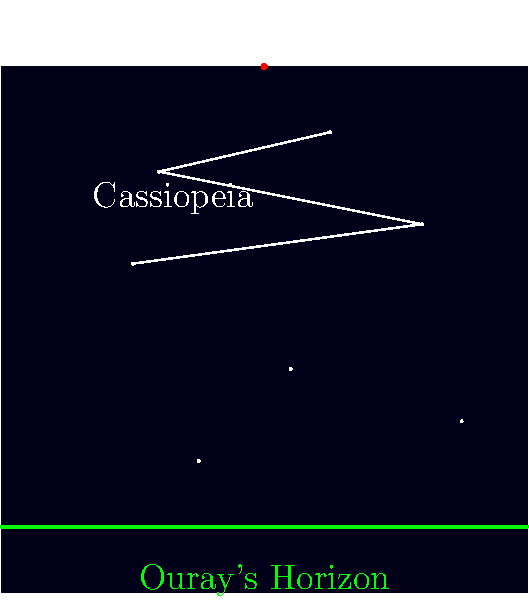Using the star chart provided, which prominent constellation is visible in Ouray's night sky, and how can it be used to locate the North Star (Polaris)? To answer this question, let's analyze the star chart step-by-step:

1. The chart shows a portion of the night sky as viewed from Ouray, Colorado.
2. We can see several stars connected by lines, forming a distinctive W or M shape.
3. This shape is labeled as "Cassiopeia," which is the prominent constellation visible in the chart.
4. Cassiopeia is a circumpolar constellation, meaning it's visible year-round from northern latitudes like Ouray.
5. To use Cassiopeia to locate Polaris (the North Star):
   a. Identify the center point of the W or M shape in Cassiopeia.
   b. Draw an imaginary line from this center point perpendicular to the open side of the W or M.
   c. Extend this line about 5 times the length of Cassiopeia.
6. In the chart, we can see that following this method leads us to a star labeled "Polaris" at the top.
7. Polaris is always located almost directly above the Earth's north celestial pole, making it an excellent reference for finding true north.

By identifying Cassiopeia and using it as a pointer, stargazers in Ouray can easily locate Polaris and determine the northern direction.
Answer: Cassiopeia; extend line from center perpendicular to open side, ~5x constellation length. 